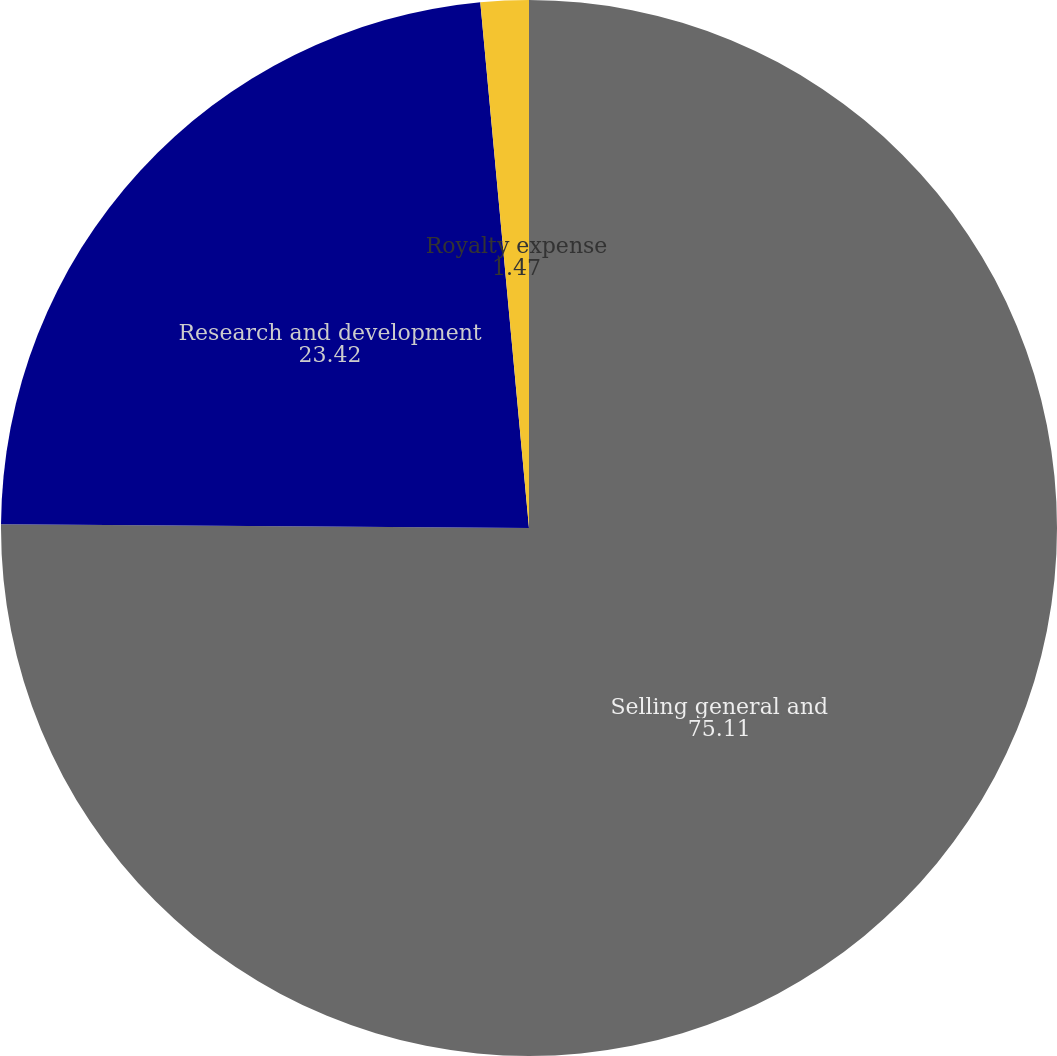Convert chart to OTSL. <chart><loc_0><loc_0><loc_500><loc_500><pie_chart><fcel>Selling general and<fcel>Research and development<fcel>Royalty expense<nl><fcel>75.11%<fcel>23.42%<fcel>1.47%<nl></chart> 